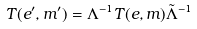Convert formula to latex. <formula><loc_0><loc_0><loc_500><loc_500>T ( e ^ { \prime } , m ^ { \prime } ) = \Lambda ^ { - 1 } T ( e , m ) \tilde { \Lambda } ^ { - 1 }</formula> 